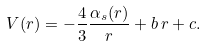Convert formula to latex. <formula><loc_0><loc_0><loc_500><loc_500>V ( r ) = - \frac { 4 } { 3 } \frac { \alpha _ { s } ( r ) } { r } + b \, r + c .</formula> 